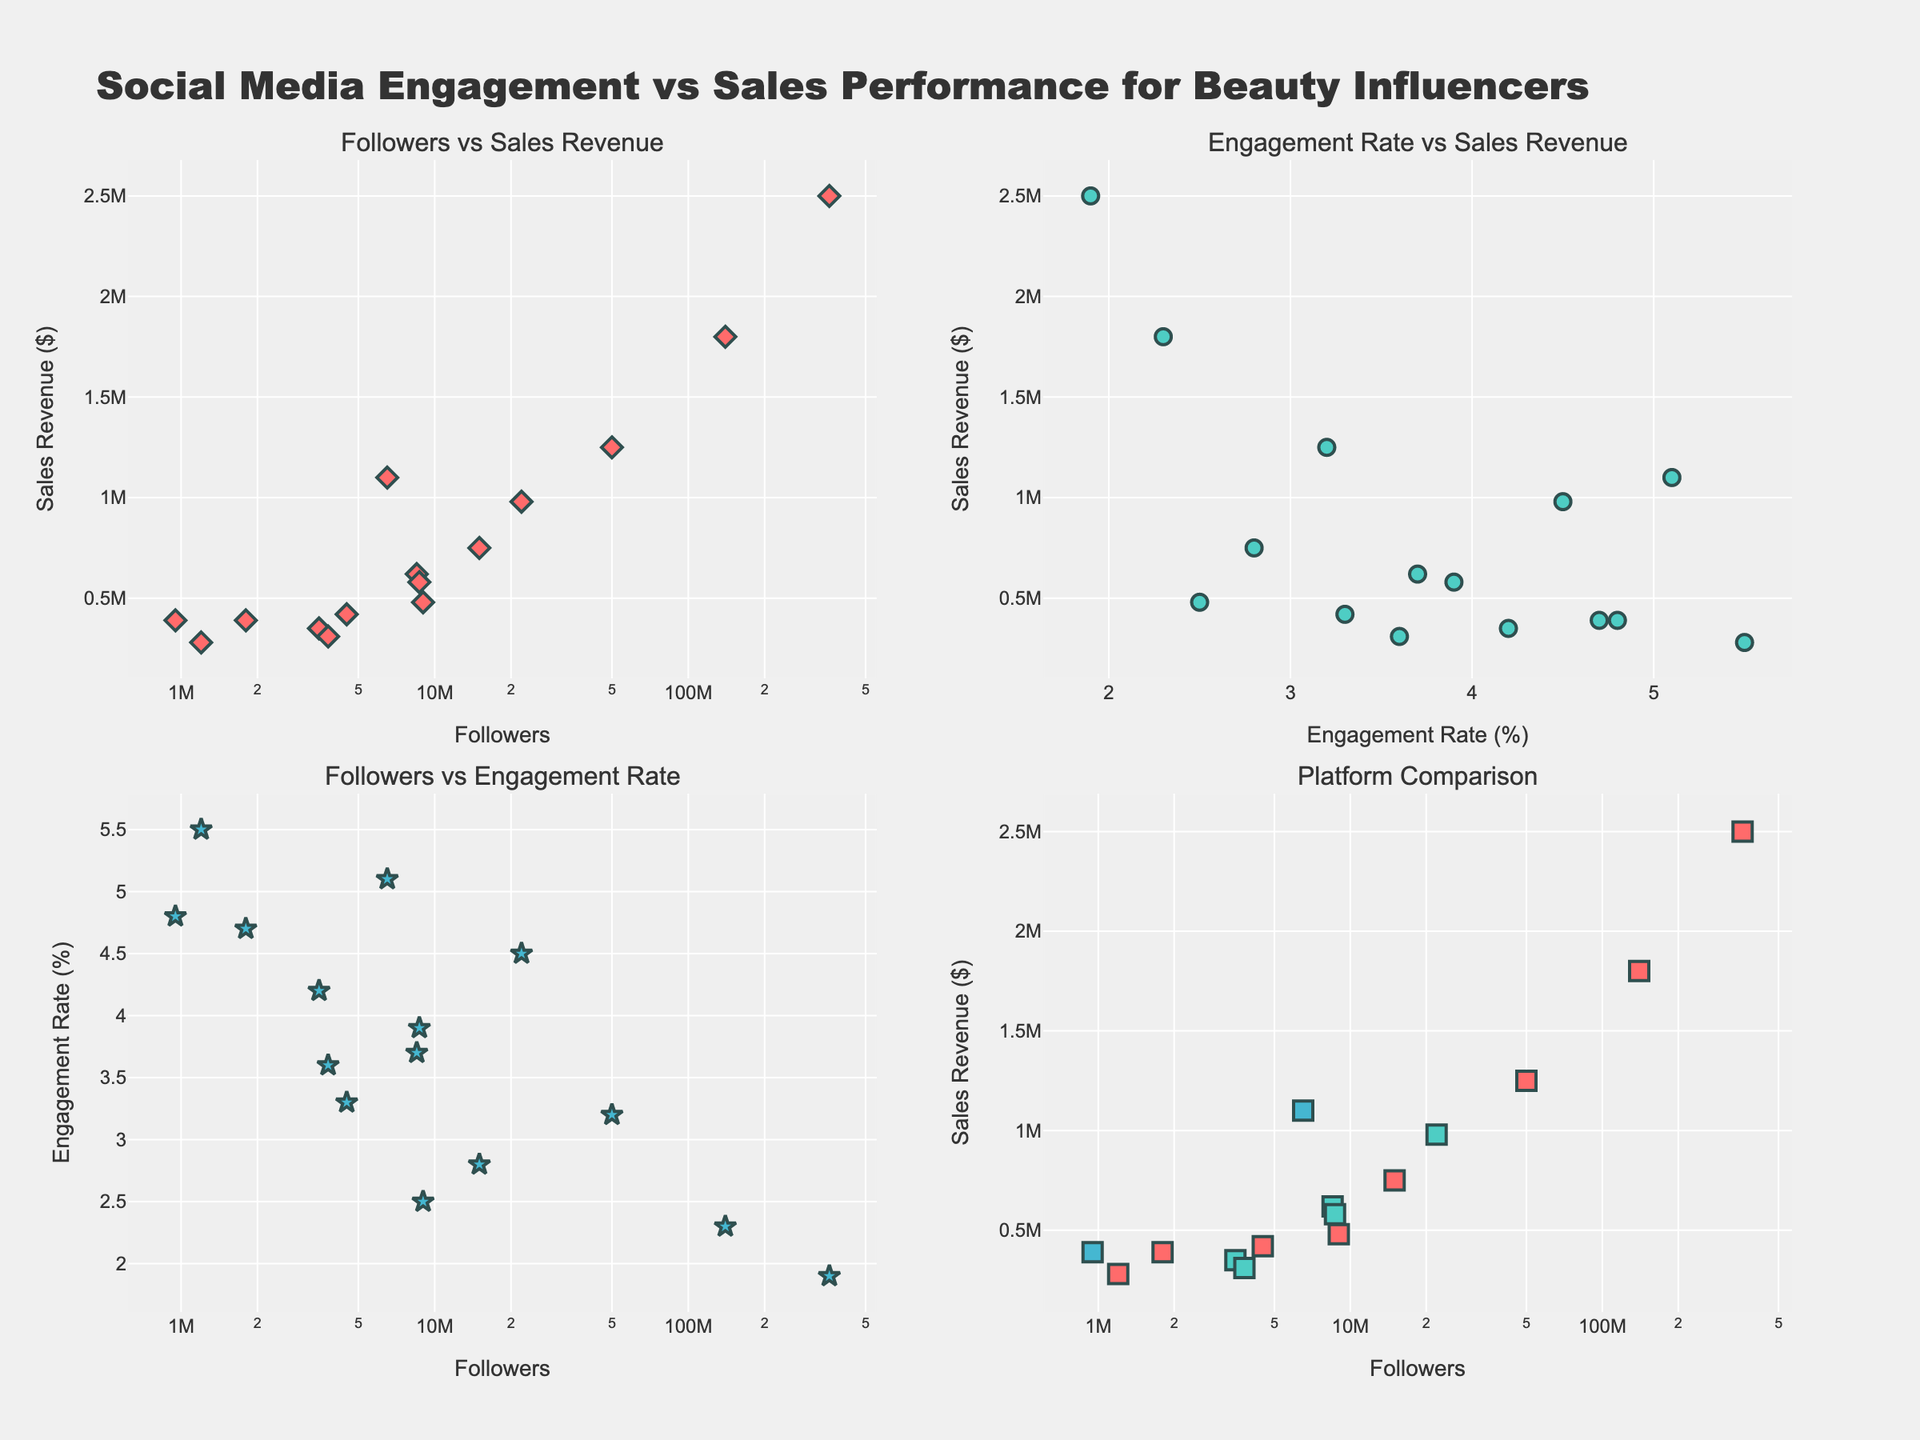How many subplots are there in the figure? The figure is divided into squares that contain small scatter plots. Each square corresponds to a subplot with its own title. By counting these squares, we see there are 4 subplots.
Answer: 4 What are the axes labels for the top left subplot? The top left subplot depicts the relationship between the number of followers (x-axis) and sales revenue (y-axis). The labels on these axes are "Followers" for the x-axis and "Sales Revenue ($)" for the y-axis.
Answer: Followers, Sales Revenue ($) Which influencer has the highest engagement rate? Looking at the scatter plot of "Followers vs Engagement Rate," we identify the influencer marked at the highest point on the y-axis. This point is represented by Nyma Tang with an engagement rate of 5.5%.
Answer: Nyma Tang Which platform has the highest number of followers represented in the bottom right subplot? By examining the bottom right subplot, each platform is represented by different colors and shapes. Instagram influencers have the highest number of followers, highlighted by Kylie Jenner with 360 million followers.
Answer: Instagram Is there a visible relationship between followers and sales revenue? Observing the "Followers vs Sales Revenue" subplot, we notice that higher follower counts generally correspond to higher sales revenue, though there are some exceptions. This indicates a positive, but not perfect, relationship between the two variables.
Answer: Yes What is the engagement rate of Jeffree Star, and did this correspond to high sales revenue? In the "Engagement Rate vs Sales Revenue" subplot, Jeffree Star's position can be identified by looking for the engagement rate of 5.1%. His sales revenue is approximately $1,100,000, indicating a strong correlation between high engagement rate and sales revenue.
Answer: 5.1%, Yes Which influencer on YouTube has the highest sales revenue? Focusing on YouTube influencers in the "Platform Comparison" subplot, we see that James Charles has the highest sales revenue, positioned significantly higher than others with sales revenue of $980,000.
Answer: James Charles Does Kylie Jenner have the highest engagement rate on Instagram? To check this, view the "Followers vs Engagement Rate" subplot for Instagram. Kylie Jenner has an engagement rate of 1.9%, which isn't the highest on Instagram. Influencers like Nyma Tang, Lisa Eldridge, and Patrick Starrr have higher engagement rates.
Answer: No What can you infer about the sales revenue for influencers with fewer than 1 million followers across different platforms? Observing influencers with fewer followers in the "Platform Comparison" subplot shows relatively lower sales revenues. Manny MUA on Twitter and Nyma Tang on Instagram, both under 1 million followers, have sales revenues of $390,000 and $280,000, respectively. This implies limited revenue potential for influencers in this follower range.
Answer: Lower sales revenue 